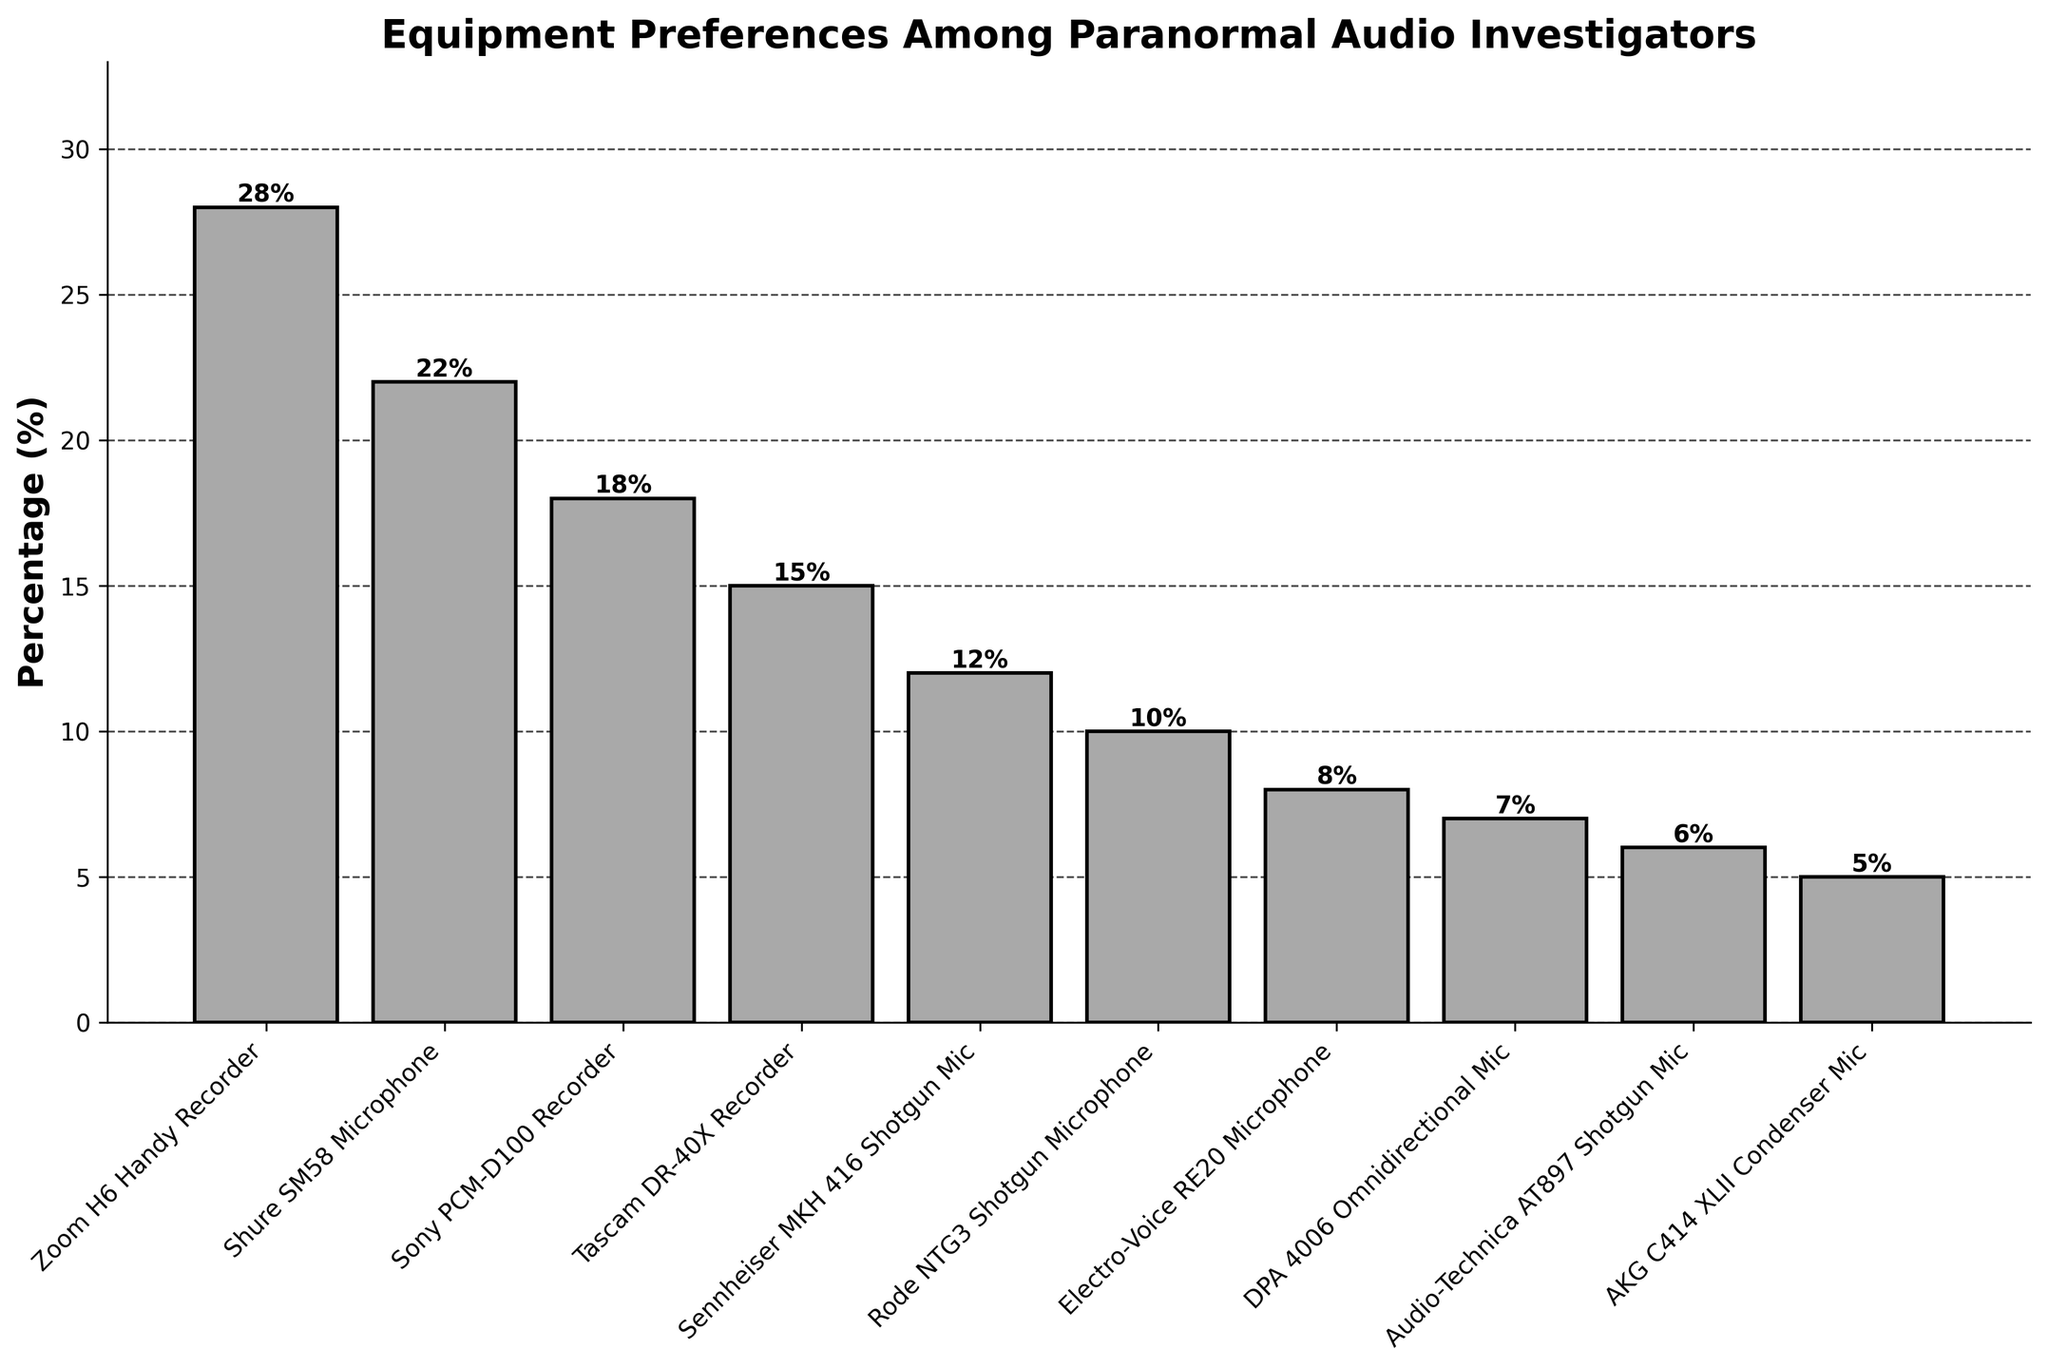What's the most preferred equipment among paranormal audio investigators? The highest bar in the bar chart corresponds to the equipment preferred by the highest percentage of paranormal audio investigators. In this case, the Zoom H6 Handy Recorder has the tallest bar at 28%.
Answer: Zoom H6 Handy Recorder Which equipment has the lowest preference among paranormal audio investigators? The shortest bar in the bar chart represents the least preferred equipment. The AKG C414 XLII Condenser Mic has the shortest bar at 5%.
Answer: AKG C414 XLII Condenser Mic What is the combined preference percentage of the top three most preferred pieces of equipment? To find the combined preference percentage, sum the percentages of the top three pieces of equipment: Zoom H6 Handy Recorder (28%), Shure SM58 Microphone (22%), and Sony PCM-D100 Recorder (18%). So, 28 + 22 + 18 = 68%.
Answer: 68% How much higher is the preference for the Zoom H6 Handy Recorder compared to the Rode NTG3 Shotgun Microphone? To find how much higher the preference is, subtract the percentage of the Rode NTG3 Shotgun Microphone (10%) from the Zoom H6 Handy Recorder (28%): 28 - 10 = 18%.
Answer: 18% Which has a higher preference: Tascam DR-40X Recorder or Sennheiser MKH 416 Shotgun Mic, and by how much? To determine which has a higher preference and by how much, compare their percentages. The Tascam DR-40X Recorder has 15%, and the Sennheiser MKH 416 Shotgun Mic has 12%. The difference is 15 - 12 = 3%.
Answer: Tascam DR-40X Recorder, 3% What is the average preference percentage of all the equipment listed? To calculate the average preference, sum all the percentages and divide by the number of equipment items: (28 + 22 + 18 + 15 + 12 + 10 + 8 + 7 + 6 + 5) / 10. This equals 131 / 10 = 13.1%.
Answer: 13.1% How many pieces of equipment have a preference percentage higher than 10%? Count the bars with percentages above 10%: Zoom H6 Handy Recorder (28%), Shure SM58 Microphone (22%), Sony PCM-D100 Recorder (18%), Tascam DR-40X Recorder (15%), and Sennheiser MKH 416 Shotgun Mic (12%). So, 5 pieces of equipment.
Answer: 5 Which two pieces of equipment have the closest preference percentages, and what are these percentages? Identify equipment with the closest bars in height. The closest percentages are Sennheiser MKH 416 Shotgun Mic (12%) and Rode NTG3 Shotgun Microphone (10%), and the difference is 2%.
Answer: Sennheiser MKH 416 Shotgun Mic and Rode NTG3 Shotgun Microphone; 12% and 10% What is the range of the preference percentages among the listed equipment? The range is the difference between the maximum and minimum percentages. The maximum is 28% (Zoom H6 Handy Recorder) and the minimum is 5% (AKG C414 XLII Condenser Mic). The range is 28 - 5 = 23%.
Answer: 23% 